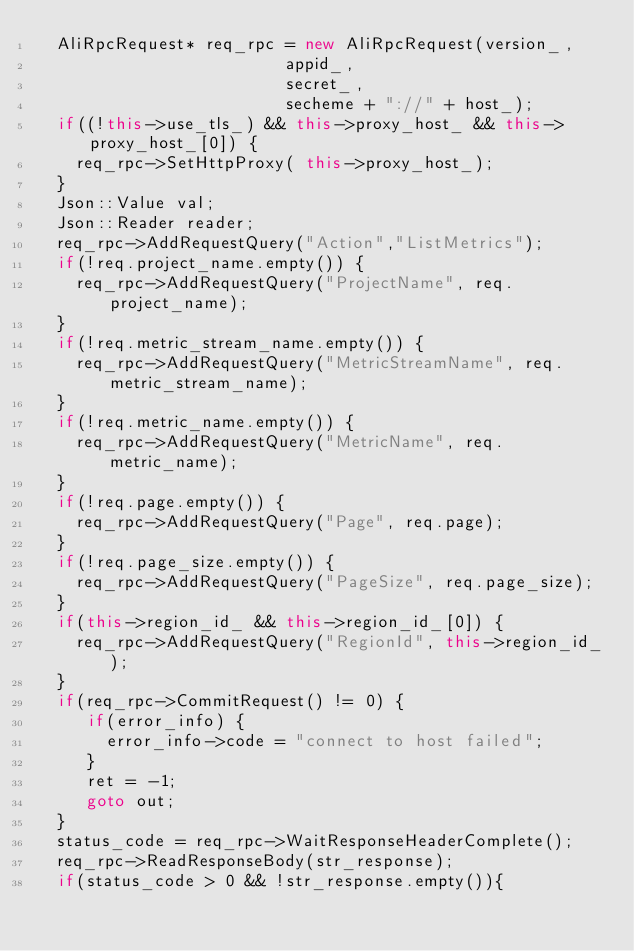<code> <loc_0><loc_0><loc_500><loc_500><_C++_>  AliRpcRequest* req_rpc = new AliRpcRequest(version_,
                         appid_,
                         secret_,
                         secheme + "://" + host_);
  if((!this->use_tls_) && this->proxy_host_ && this->proxy_host_[0]) {
    req_rpc->SetHttpProxy( this->proxy_host_);
  }
  Json::Value val;
  Json::Reader reader;
  req_rpc->AddRequestQuery("Action","ListMetrics");
  if(!req.project_name.empty()) {
    req_rpc->AddRequestQuery("ProjectName", req.project_name);
  }
  if(!req.metric_stream_name.empty()) {
    req_rpc->AddRequestQuery("MetricStreamName", req.metric_stream_name);
  }
  if(!req.metric_name.empty()) {
    req_rpc->AddRequestQuery("MetricName", req.metric_name);
  }
  if(!req.page.empty()) {
    req_rpc->AddRequestQuery("Page", req.page);
  }
  if(!req.page_size.empty()) {
    req_rpc->AddRequestQuery("PageSize", req.page_size);
  }
  if(this->region_id_ && this->region_id_[0]) {
    req_rpc->AddRequestQuery("RegionId", this->region_id_);
  }
  if(req_rpc->CommitRequest() != 0) {
     if(error_info) {
       error_info->code = "connect to host failed";
     }
     ret = -1;
     goto out;
  }
  status_code = req_rpc->WaitResponseHeaderComplete();
  req_rpc->ReadResponseBody(str_response);
  if(status_code > 0 && !str_response.empty()){</code> 